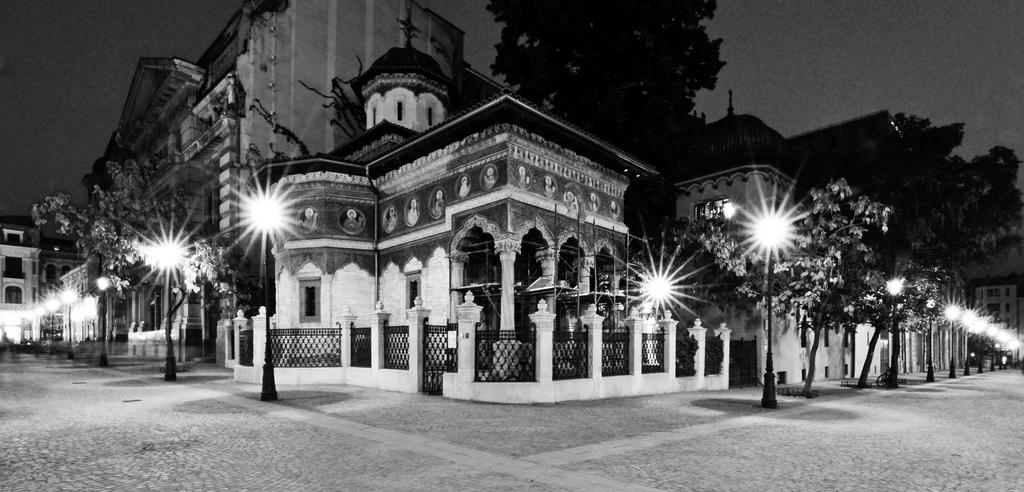What type of structures can be seen in the image? There are buildings in the image. What natural elements are present in the image? There are trees in the image. What are the vertical objects in the image? There are poles in the image. What are the illuminated objects in the image? There are lights in the image. What can be seen in the background of the image? The sky is visible in the background of the image. Where is the nest located in the image? There is no nest present in the image. What type of pets can be seen in the image? There are no pets visible in the image. 